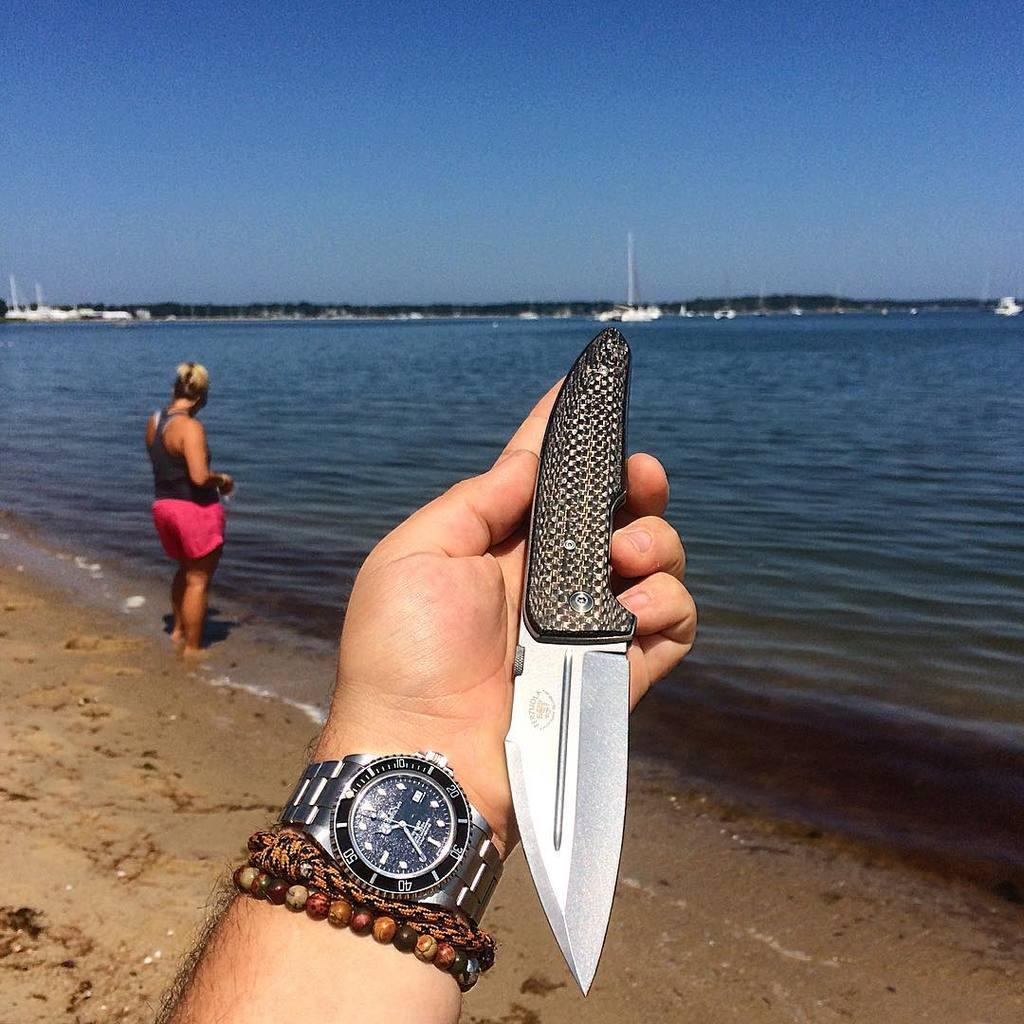<image>
Share a concise interpretation of the image provided. A person is holding up a knife that has a brand name that ends with the letter A. 